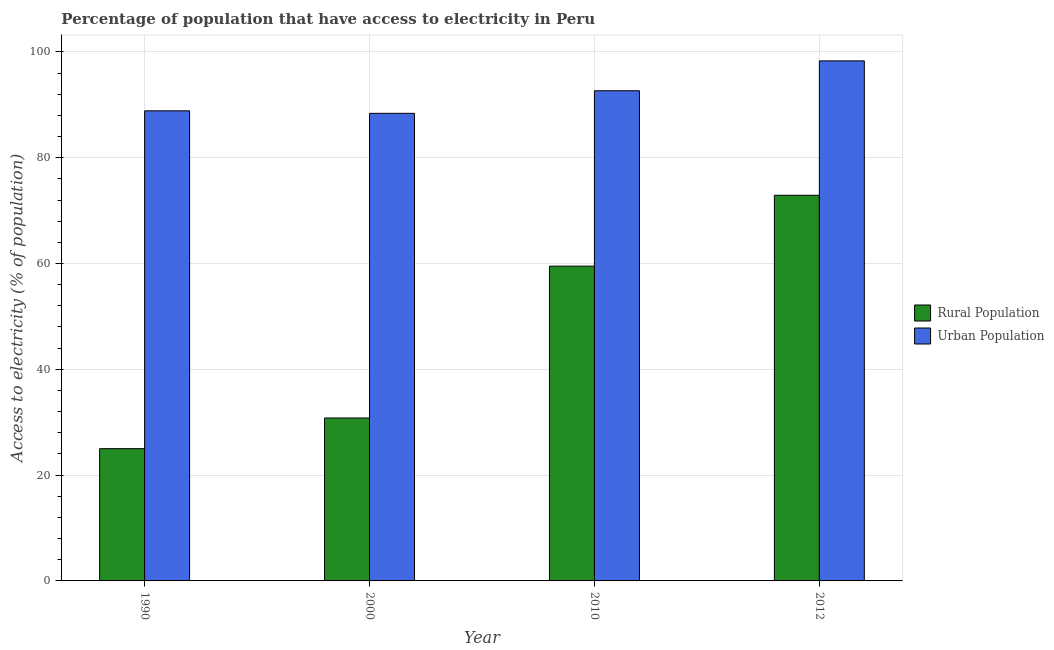How many different coloured bars are there?
Offer a very short reply. 2. Are the number of bars per tick equal to the number of legend labels?
Offer a terse response. Yes. Are the number of bars on each tick of the X-axis equal?
Give a very brief answer. Yes. How many bars are there on the 1st tick from the left?
Keep it short and to the point. 2. How many bars are there on the 4th tick from the right?
Provide a succinct answer. 2. In how many cases, is the number of bars for a given year not equal to the number of legend labels?
Your answer should be very brief. 0. What is the percentage of urban population having access to electricity in 2010?
Ensure brevity in your answer.  92.66. Across all years, what is the maximum percentage of urban population having access to electricity?
Make the answer very short. 98.3. In which year was the percentage of rural population having access to electricity maximum?
Your response must be concise. 2012. What is the total percentage of rural population having access to electricity in the graph?
Your answer should be very brief. 188.2. What is the difference between the percentage of urban population having access to electricity in 2000 and that in 2010?
Provide a short and direct response. -4.27. What is the difference between the percentage of urban population having access to electricity in 1990 and the percentage of rural population having access to electricity in 2012?
Your answer should be very brief. -9.44. What is the average percentage of rural population having access to electricity per year?
Your response must be concise. 47.05. In how many years, is the percentage of urban population having access to electricity greater than 56 %?
Provide a short and direct response. 4. What is the ratio of the percentage of rural population having access to electricity in 2010 to that in 2012?
Your response must be concise. 0.82. Is the percentage of rural population having access to electricity in 2000 less than that in 2012?
Keep it short and to the point. Yes. Is the difference between the percentage of rural population having access to electricity in 1990 and 2000 greater than the difference between the percentage of urban population having access to electricity in 1990 and 2000?
Keep it short and to the point. No. What is the difference between the highest and the second highest percentage of rural population having access to electricity?
Provide a short and direct response. 13.4. What is the difference between the highest and the lowest percentage of urban population having access to electricity?
Your answer should be compact. 9.91. What does the 2nd bar from the left in 2010 represents?
Provide a succinct answer. Urban Population. What does the 1st bar from the right in 2000 represents?
Your answer should be compact. Urban Population. How many bars are there?
Offer a terse response. 8. Are all the bars in the graph horizontal?
Make the answer very short. No. How many years are there in the graph?
Your response must be concise. 4. Are the values on the major ticks of Y-axis written in scientific E-notation?
Your answer should be very brief. No. Does the graph contain any zero values?
Your response must be concise. No. Does the graph contain grids?
Ensure brevity in your answer.  Yes. Where does the legend appear in the graph?
Offer a terse response. Center right. How many legend labels are there?
Give a very brief answer. 2. What is the title of the graph?
Give a very brief answer. Percentage of population that have access to electricity in Peru. What is the label or title of the X-axis?
Your answer should be very brief. Year. What is the label or title of the Y-axis?
Offer a very short reply. Access to electricity (% of population). What is the Access to electricity (% of population) of Rural Population in 1990?
Offer a very short reply. 25. What is the Access to electricity (% of population) of Urban Population in 1990?
Offer a terse response. 88.86. What is the Access to electricity (% of population) of Rural Population in 2000?
Make the answer very short. 30.8. What is the Access to electricity (% of population) in Urban Population in 2000?
Offer a terse response. 88.39. What is the Access to electricity (% of population) in Rural Population in 2010?
Your answer should be compact. 59.5. What is the Access to electricity (% of population) of Urban Population in 2010?
Your answer should be compact. 92.66. What is the Access to electricity (% of population) in Rural Population in 2012?
Your response must be concise. 72.9. What is the Access to electricity (% of population) in Urban Population in 2012?
Offer a very short reply. 98.3. Across all years, what is the maximum Access to electricity (% of population) of Rural Population?
Ensure brevity in your answer.  72.9. Across all years, what is the maximum Access to electricity (% of population) of Urban Population?
Your response must be concise. 98.3. Across all years, what is the minimum Access to electricity (% of population) of Rural Population?
Provide a succinct answer. 25. Across all years, what is the minimum Access to electricity (% of population) in Urban Population?
Keep it short and to the point. 88.39. What is the total Access to electricity (% of population) in Rural Population in the graph?
Offer a terse response. 188.2. What is the total Access to electricity (% of population) in Urban Population in the graph?
Offer a very short reply. 368.2. What is the difference between the Access to electricity (% of population) in Rural Population in 1990 and that in 2000?
Give a very brief answer. -5.8. What is the difference between the Access to electricity (% of population) of Urban Population in 1990 and that in 2000?
Ensure brevity in your answer.  0.47. What is the difference between the Access to electricity (% of population) of Rural Population in 1990 and that in 2010?
Give a very brief answer. -34.5. What is the difference between the Access to electricity (% of population) of Urban Population in 1990 and that in 2010?
Your answer should be very brief. -3.8. What is the difference between the Access to electricity (% of population) of Rural Population in 1990 and that in 2012?
Your answer should be very brief. -47.9. What is the difference between the Access to electricity (% of population) in Urban Population in 1990 and that in 2012?
Offer a terse response. -9.44. What is the difference between the Access to electricity (% of population) in Rural Population in 2000 and that in 2010?
Offer a terse response. -28.7. What is the difference between the Access to electricity (% of population) of Urban Population in 2000 and that in 2010?
Offer a terse response. -4.27. What is the difference between the Access to electricity (% of population) of Rural Population in 2000 and that in 2012?
Your answer should be very brief. -42.1. What is the difference between the Access to electricity (% of population) of Urban Population in 2000 and that in 2012?
Provide a short and direct response. -9.91. What is the difference between the Access to electricity (% of population) in Urban Population in 2010 and that in 2012?
Provide a succinct answer. -5.64. What is the difference between the Access to electricity (% of population) in Rural Population in 1990 and the Access to electricity (% of population) in Urban Population in 2000?
Give a very brief answer. -63.39. What is the difference between the Access to electricity (% of population) of Rural Population in 1990 and the Access to electricity (% of population) of Urban Population in 2010?
Keep it short and to the point. -67.66. What is the difference between the Access to electricity (% of population) of Rural Population in 1990 and the Access to electricity (% of population) of Urban Population in 2012?
Ensure brevity in your answer.  -73.3. What is the difference between the Access to electricity (% of population) of Rural Population in 2000 and the Access to electricity (% of population) of Urban Population in 2010?
Give a very brief answer. -61.86. What is the difference between the Access to electricity (% of population) in Rural Population in 2000 and the Access to electricity (% of population) in Urban Population in 2012?
Your response must be concise. -67.5. What is the difference between the Access to electricity (% of population) in Rural Population in 2010 and the Access to electricity (% of population) in Urban Population in 2012?
Your response must be concise. -38.8. What is the average Access to electricity (% of population) in Rural Population per year?
Your response must be concise. 47.05. What is the average Access to electricity (% of population) of Urban Population per year?
Offer a very short reply. 92.05. In the year 1990, what is the difference between the Access to electricity (% of population) of Rural Population and Access to electricity (% of population) of Urban Population?
Offer a very short reply. -63.86. In the year 2000, what is the difference between the Access to electricity (% of population) in Rural Population and Access to electricity (% of population) in Urban Population?
Your response must be concise. -57.59. In the year 2010, what is the difference between the Access to electricity (% of population) of Rural Population and Access to electricity (% of population) of Urban Population?
Make the answer very short. -33.16. In the year 2012, what is the difference between the Access to electricity (% of population) in Rural Population and Access to electricity (% of population) in Urban Population?
Keep it short and to the point. -25.4. What is the ratio of the Access to electricity (% of population) of Rural Population in 1990 to that in 2000?
Your answer should be very brief. 0.81. What is the ratio of the Access to electricity (% of population) in Urban Population in 1990 to that in 2000?
Your answer should be very brief. 1.01. What is the ratio of the Access to electricity (% of population) of Rural Population in 1990 to that in 2010?
Your answer should be very brief. 0.42. What is the ratio of the Access to electricity (% of population) in Rural Population in 1990 to that in 2012?
Offer a very short reply. 0.34. What is the ratio of the Access to electricity (% of population) of Urban Population in 1990 to that in 2012?
Offer a very short reply. 0.9. What is the ratio of the Access to electricity (% of population) of Rural Population in 2000 to that in 2010?
Keep it short and to the point. 0.52. What is the ratio of the Access to electricity (% of population) in Urban Population in 2000 to that in 2010?
Your response must be concise. 0.95. What is the ratio of the Access to electricity (% of population) of Rural Population in 2000 to that in 2012?
Provide a short and direct response. 0.42. What is the ratio of the Access to electricity (% of population) in Urban Population in 2000 to that in 2012?
Your answer should be compact. 0.9. What is the ratio of the Access to electricity (% of population) of Rural Population in 2010 to that in 2012?
Keep it short and to the point. 0.82. What is the ratio of the Access to electricity (% of population) in Urban Population in 2010 to that in 2012?
Make the answer very short. 0.94. What is the difference between the highest and the second highest Access to electricity (% of population) of Rural Population?
Provide a succinct answer. 13.4. What is the difference between the highest and the second highest Access to electricity (% of population) in Urban Population?
Offer a terse response. 5.64. What is the difference between the highest and the lowest Access to electricity (% of population) of Rural Population?
Offer a very short reply. 47.9. What is the difference between the highest and the lowest Access to electricity (% of population) in Urban Population?
Offer a terse response. 9.91. 